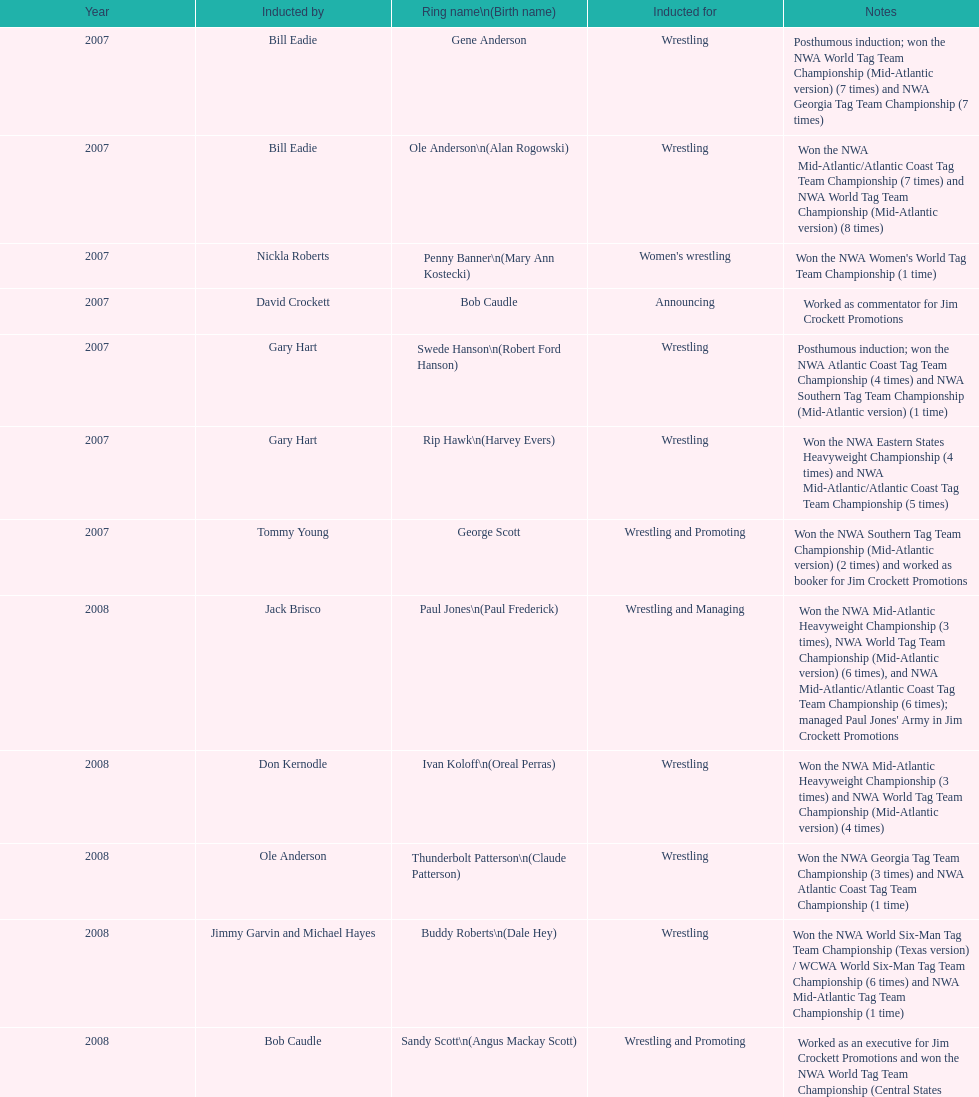Tell me an inductee that was not living at the time. Gene Anderson. 